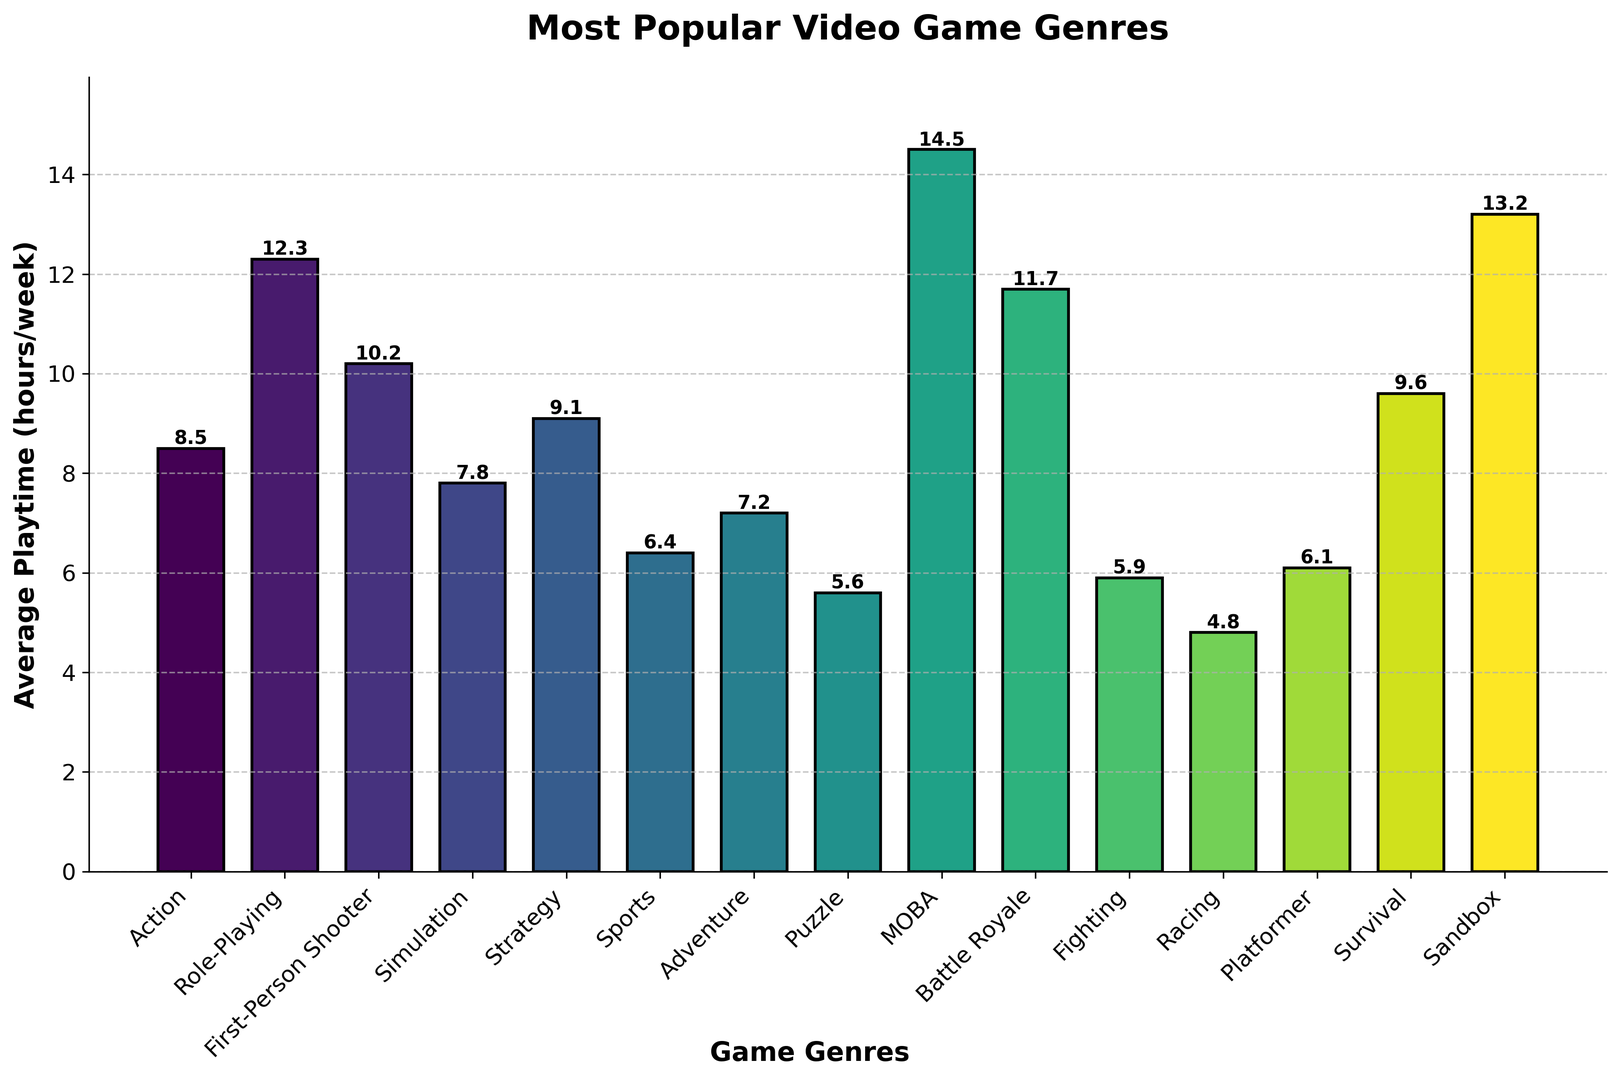Which genre has the highest average playtime per week? By examining the lengths of the bars, we can see that MOBA has the highest bar, indicating the greatest average weekly playtime. The number on top of this bar reads 14.5.
Answer: MOBA Which genre has the lowest average playtime per week? By examining the lengths of the bars, the shortest bar indicates the lowest average weekly playtime. The Racing genre has the shortest bar with a value of 4.8 hours.
Answer: Racing What's the difference in average playtime between Role-Playing and First-Person Shooter genres? For Role-Playing, the average playtime is 12.3 hours, and for First-Person Shooter, it is 10.2 hours. Subtracting these gives us 12.3 - 10.2 = 2.1 hours.
Answer: 2.1 hours Which genres have an average playtime greater than 10 hours per week? Checking the figure, the genres with bars reaching above 10 hours are MOBA, Sandbox, Role-Playing, and Battle Royale.
Answer: MOBA, Sandbox, Role-Playing, Battle Royale How much more do gamers play MOBA than Strategy games on average per week? Average playtime for MOBA is 14.5 hours, and for Strategy, it is 9.1 hours. The difference is 14.5 - 9.1 = 5.4 hours.
Answer: 5.4 hours What is the combined average playtime per week for Fighting and Racing genres? The average playtime for Fighting is 5.9 hours, and for Racing, it is 4.8 hours. Summing these gives 5.9 + 4.8 = 10.7 hours.
Answer: 10.7 hours Which genre is the third most popular in terms of average playtime? Sorting the bars by height, the third highest is the Battle Royale genre with an average playtime of 11.7 hours per week.
Answer: Battle Royale Are there any genres with average playtimes less than 6 hours per week? If yes, which are they? By examining the bars, the genres with playtimes below 6 hours are Puzzle, Racing, and Fighting.
Answer: Puzzle, Racing, Fighting On average, do gamers spend more time playing Adventure games or Sports games? By comparing the heights of the bars, Adventure games have an average playtime of 7.2 hours, while Sports games have 6.4 hours. Therefore, Adventure games have more playtime.
Answer: Adventure games 